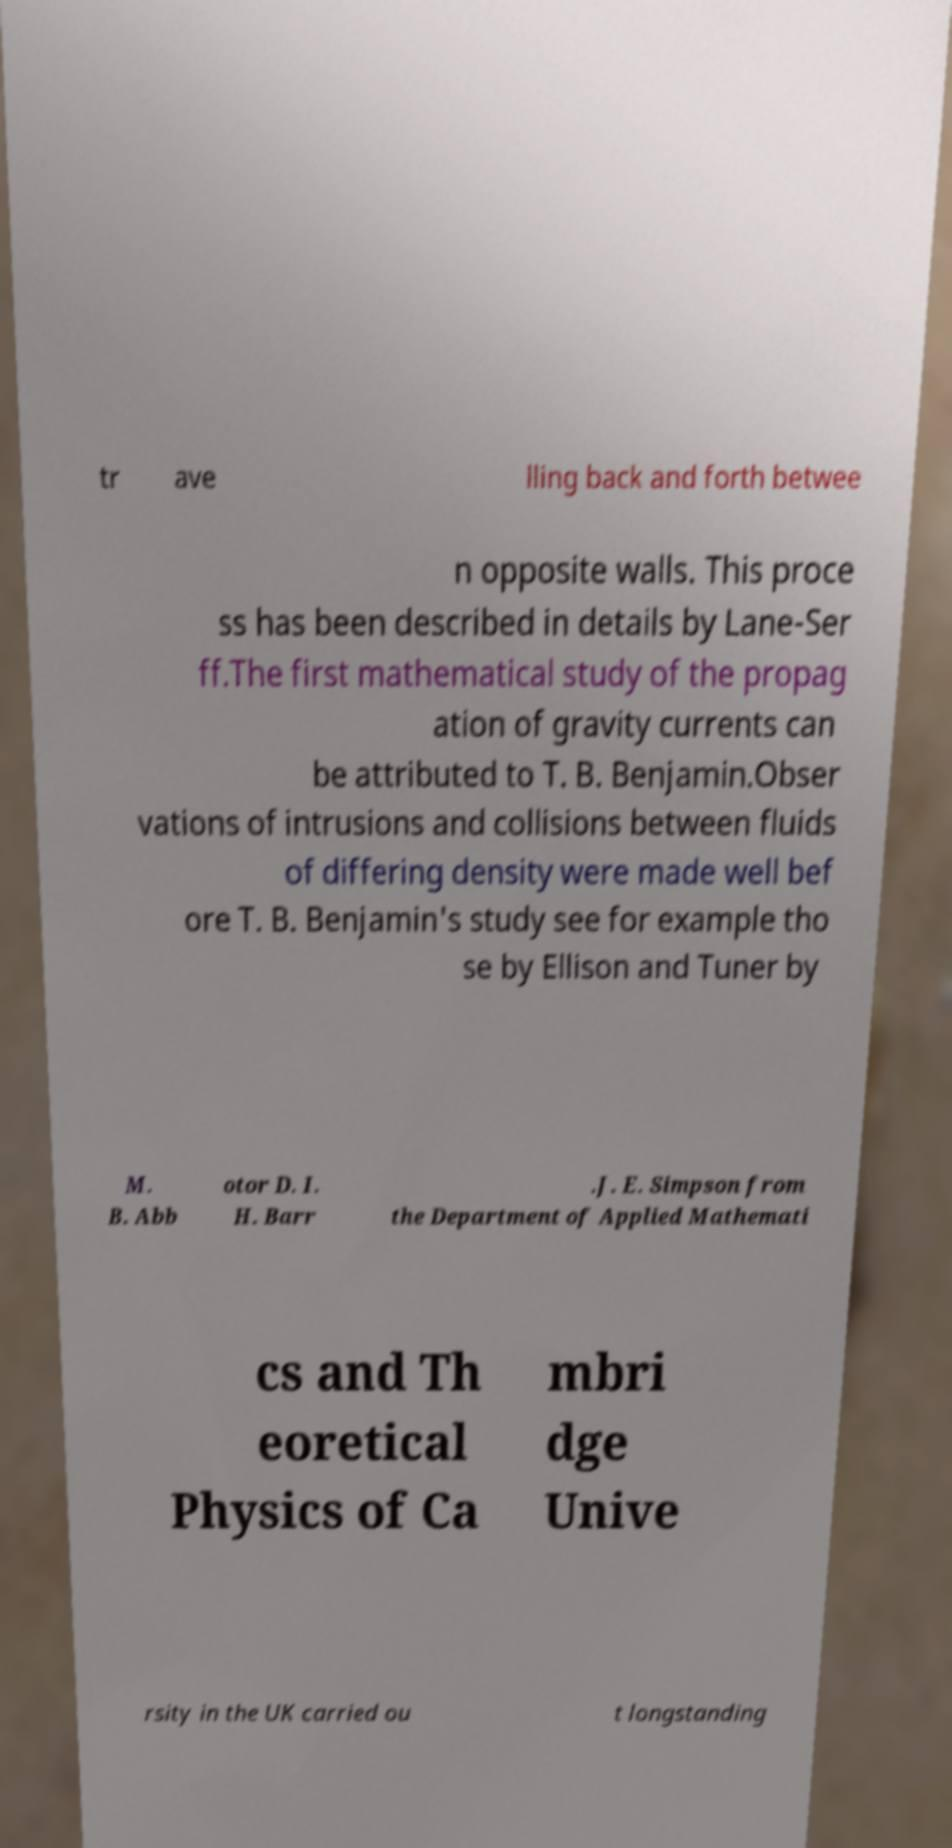Could you extract and type out the text from this image? tr ave lling back and forth betwee n opposite walls. This proce ss has been described in details by Lane-Ser ff.The first mathematical study of the propag ation of gravity currents can be attributed to T. B. Benjamin.Obser vations of intrusions and collisions between fluids of differing density were made well bef ore T. B. Benjamin's study see for example tho se by Ellison and Tuner by M. B. Abb otor D. I. H. Barr .J. E. Simpson from the Department of Applied Mathemati cs and Th eoretical Physics of Ca mbri dge Unive rsity in the UK carried ou t longstanding 